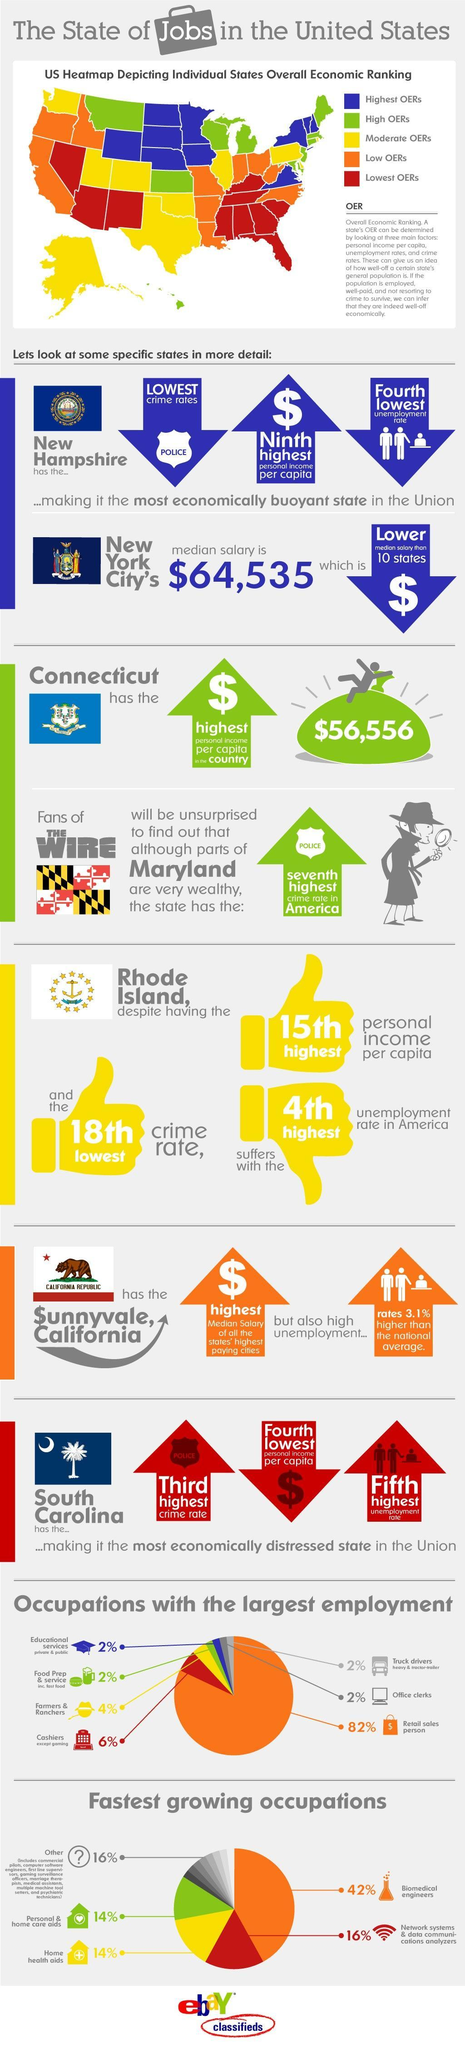How many states in USA has low OERs?
Answer the question with a short phrase. 10 Which color is used to map the states with High OERs- yellow, red, violet, green? green How many states in USA has lowest OERs? 10 How many states in USA has highest OERs? 10 Which occupation has marked the second largest employment? Cashiers except gaming Into how many different economic rankings the US state is divided? 5 What is the overall economic ranking of the left most island in the info graphic? Moderate OERs How many occupations in USA have employment rate equal to  2%? 4 What is the overall economic ranking of the centre most island in the info graphic? High OERs Which place in United states has the 4th highest unemployment rate? Rhode Island 